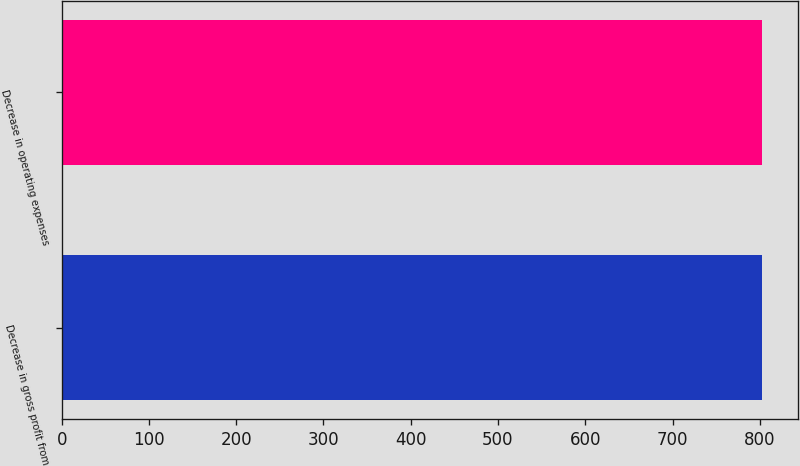<chart> <loc_0><loc_0><loc_500><loc_500><bar_chart><fcel>Decrease in gross profit from<fcel>Decrease in operating expenses<nl><fcel>803<fcel>803.1<nl></chart> 